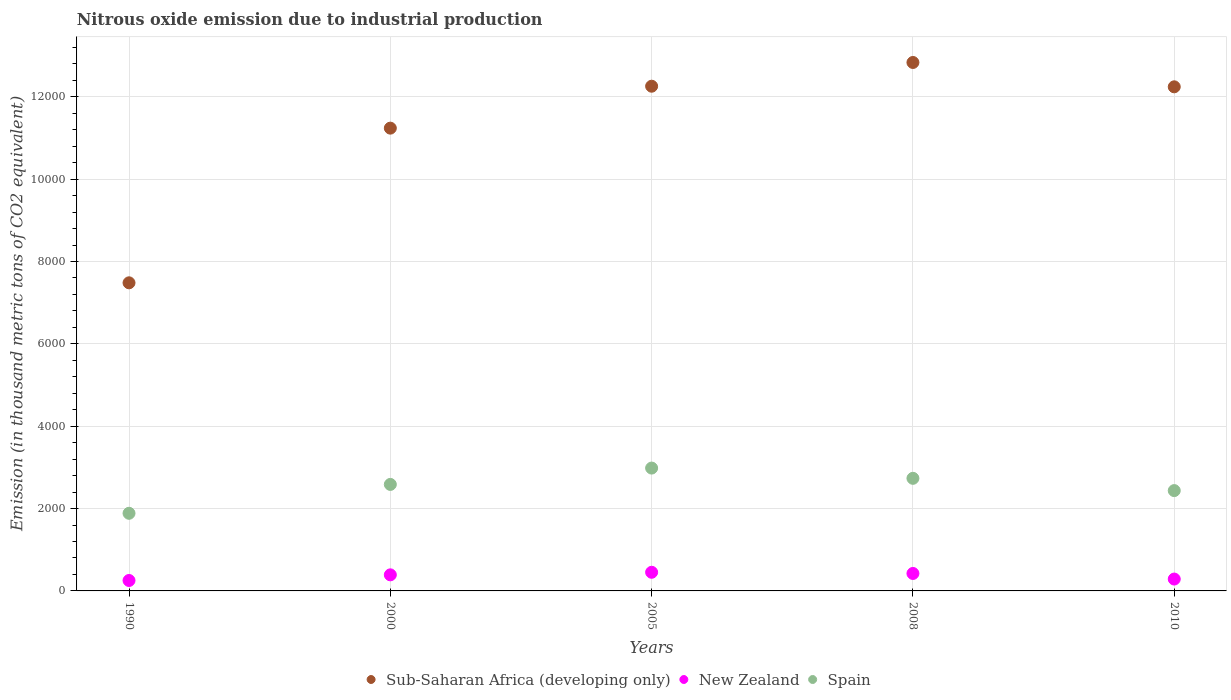Is the number of dotlines equal to the number of legend labels?
Provide a succinct answer. Yes. What is the amount of nitrous oxide emitted in New Zealand in 1990?
Offer a terse response. 253.4. Across all years, what is the maximum amount of nitrous oxide emitted in Spain?
Ensure brevity in your answer.  2983.4. Across all years, what is the minimum amount of nitrous oxide emitted in Sub-Saharan Africa (developing only)?
Make the answer very short. 7482.3. In which year was the amount of nitrous oxide emitted in New Zealand maximum?
Offer a terse response. 2005. What is the total amount of nitrous oxide emitted in New Zealand in the graph?
Offer a terse response. 1808.9. What is the difference between the amount of nitrous oxide emitted in Sub-Saharan Africa (developing only) in 1990 and that in 2010?
Keep it short and to the point. -4759.9. What is the difference between the amount of nitrous oxide emitted in Spain in 2010 and the amount of nitrous oxide emitted in New Zealand in 2008?
Offer a terse response. 2012.4. What is the average amount of nitrous oxide emitted in Sub-Saharan Africa (developing only) per year?
Provide a short and direct response. 1.12e+04. In the year 2000, what is the difference between the amount of nitrous oxide emitted in Spain and amount of nitrous oxide emitted in Sub-Saharan Africa (developing only)?
Your answer should be compact. -8652.2. What is the ratio of the amount of nitrous oxide emitted in Spain in 2008 to that in 2010?
Give a very brief answer. 1.12. What is the difference between the highest and the second highest amount of nitrous oxide emitted in Sub-Saharan Africa (developing only)?
Your answer should be very brief. 576.6. What is the difference between the highest and the lowest amount of nitrous oxide emitted in Spain?
Provide a succinct answer. 1098.1. Is the sum of the amount of nitrous oxide emitted in Sub-Saharan Africa (developing only) in 2008 and 2010 greater than the maximum amount of nitrous oxide emitted in New Zealand across all years?
Ensure brevity in your answer.  Yes. Does the amount of nitrous oxide emitted in Sub-Saharan Africa (developing only) monotonically increase over the years?
Your answer should be very brief. No. How many dotlines are there?
Your answer should be very brief. 3. How many years are there in the graph?
Offer a very short reply. 5. Are the values on the major ticks of Y-axis written in scientific E-notation?
Offer a very short reply. No. How are the legend labels stacked?
Give a very brief answer. Horizontal. What is the title of the graph?
Your answer should be compact. Nitrous oxide emission due to industrial production. What is the label or title of the Y-axis?
Provide a succinct answer. Emission (in thousand metric tons of CO2 equivalent). What is the Emission (in thousand metric tons of CO2 equivalent) of Sub-Saharan Africa (developing only) in 1990?
Provide a succinct answer. 7482.3. What is the Emission (in thousand metric tons of CO2 equivalent) in New Zealand in 1990?
Keep it short and to the point. 253.4. What is the Emission (in thousand metric tons of CO2 equivalent) of Spain in 1990?
Offer a very short reply. 1885.3. What is the Emission (in thousand metric tons of CO2 equivalent) in Sub-Saharan Africa (developing only) in 2000?
Your response must be concise. 1.12e+04. What is the Emission (in thousand metric tons of CO2 equivalent) in New Zealand in 2000?
Make the answer very short. 390.5. What is the Emission (in thousand metric tons of CO2 equivalent) of Spain in 2000?
Your response must be concise. 2586.5. What is the Emission (in thousand metric tons of CO2 equivalent) of Sub-Saharan Africa (developing only) in 2005?
Provide a succinct answer. 1.23e+04. What is the Emission (in thousand metric tons of CO2 equivalent) in New Zealand in 2005?
Your answer should be very brief. 452.7. What is the Emission (in thousand metric tons of CO2 equivalent) of Spain in 2005?
Your answer should be very brief. 2983.4. What is the Emission (in thousand metric tons of CO2 equivalent) in Sub-Saharan Africa (developing only) in 2008?
Ensure brevity in your answer.  1.28e+04. What is the Emission (in thousand metric tons of CO2 equivalent) in New Zealand in 2008?
Provide a short and direct response. 424. What is the Emission (in thousand metric tons of CO2 equivalent) of Spain in 2008?
Your answer should be compact. 2734.4. What is the Emission (in thousand metric tons of CO2 equivalent) of Sub-Saharan Africa (developing only) in 2010?
Offer a very short reply. 1.22e+04. What is the Emission (in thousand metric tons of CO2 equivalent) of New Zealand in 2010?
Offer a very short reply. 288.3. What is the Emission (in thousand metric tons of CO2 equivalent) in Spain in 2010?
Your response must be concise. 2436.4. Across all years, what is the maximum Emission (in thousand metric tons of CO2 equivalent) of Sub-Saharan Africa (developing only)?
Make the answer very short. 1.28e+04. Across all years, what is the maximum Emission (in thousand metric tons of CO2 equivalent) in New Zealand?
Provide a succinct answer. 452.7. Across all years, what is the maximum Emission (in thousand metric tons of CO2 equivalent) in Spain?
Provide a succinct answer. 2983.4. Across all years, what is the minimum Emission (in thousand metric tons of CO2 equivalent) of Sub-Saharan Africa (developing only)?
Provide a succinct answer. 7482.3. Across all years, what is the minimum Emission (in thousand metric tons of CO2 equivalent) of New Zealand?
Give a very brief answer. 253.4. Across all years, what is the minimum Emission (in thousand metric tons of CO2 equivalent) in Spain?
Keep it short and to the point. 1885.3. What is the total Emission (in thousand metric tons of CO2 equivalent) in Sub-Saharan Africa (developing only) in the graph?
Provide a succinct answer. 5.61e+04. What is the total Emission (in thousand metric tons of CO2 equivalent) in New Zealand in the graph?
Your answer should be very brief. 1808.9. What is the total Emission (in thousand metric tons of CO2 equivalent) of Spain in the graph?
Provide a short and direct response. 1.26e+04. What is the difference between the Emission (in thousand metric tons of CO2 equivalent) of Sub-Saharan Africa (developing only) in 1990 and that in 2000?
Your answer should be very brief. -3756.4. What is the difference between the Emission (in thousand metric tons of CO2 equivalent) in New Zealand in 1990 and that in 2000?
Offer a terse response. -137.1. What is the difference between the Emission (in thousand metric tons of CO2 equivalent) in Spain in 1990 and that in 2000?
Give a very brief answer. -701.2. What is the difference between the Emission (in thousand metric tons of CO2 equivalent) in Sub-Saharan Africa (developing only) in 1990 and that in 2005?
Your response must be concise. -4774.5. What is the difference between the Emission (in thousand metric tons of CO2 equivalent) in New Zealand in 1990 and that in 2005?
Your response must be concise. -199.3. What is the difference between the Emission (in thousand metric tons of CO2 equivalent) of Spain in 1990 and that in 2005?
Offer a very short reply. -1098.1. What is the difference between the Emission (in thousand metric tons of CO2 equivalent) in Sub-Saharan Africa (developing only) in 1990 and that in 2008?
Make the answer very short. -5351.1. What is the difference between the Emission (in thousand metric tons of CO2 equivalent) in New Zealand in 1990 and that in 2008?
Give a very brief answer. -170.6. What is the difference between the Emission (in thousand metric tons of CO2 equivalent) of Spain in 1990 and that in 2008?
Your answer should be very brief. -849.1. What is the difference between the Emission (in thousand metric tons of CO2 equivalent) of Sub-Saharan Africa (developing only) in 1990 and that in 2010?
Give a very brief answer. -4759.9. What is the difference between the Emission (in thousand metric tons of CO2 equivalent) of New Zealand in 1990 and that in 2010?
Your response must be concise. -34.9. What is the difference between the Emission (in thousand metric tons of CO2 equivalent) in Spain in 1990 and that in 2010?
Keep it short and to the point. -551.1. What is the difference between the Emission (in thousand metric tons of CO2 equivalent) of Sub-Saharan Africa (developing only) in 2000 and that in 2005?
Keep it short and to the point. -1018.1. What is the difference between the Emission (in thousand metric tons of CO2 equivalent) in New Zealand in 2000 and that in 2005?
Provide a short and direct response. -62.2. What is the difference between the Emission (in thousand metric tons of CO2 equivalent) in Spain in 2000 and that in 2005?
Ensure brevity in your answer.  -396.9. What is the difference between the Emission (in thousand metric tons of CO2 equivalent) of Sub-Saharan Africa (developing only) in 2000 and that in 2008?
Your answer should be very brief. -1594.7. What is the difference between the Emission (in thousand metric tons of CO2 equivalent) in New Zealand in 2000 and that in 2008?
Keep it short and to the point. -33.5. What is the difference between the Emission (in thousand metric tons of CO2 equivalent) in Spain in 2000 and that in 2008?
Your response must be concise. -147.9. What is the difference between the Emission (in thousand metric tons of CO2 equivalent) of Sub-Saharan Africa (developing only) in 2000 and that in 2010?
Ensure brevity in your answer.  -1003.5. What is the difference between the Emission (in thousand metric tons of CO2 equivalent) of New Zealand in 2000 and that in 2010?
Offer a terse response. 102.2. What is the difference between the Emission (in thousand metric tons of CO2 equivalent) of Spain in 2000 and that in 2010?
Your answer should be compact. 150.1. What is the difference between the Emission (in thousand metric tons of CO2 equivalent) of Sub-Saharan Africa (developing only) in 2005 and that in 2008?
Ensure brevity in your answer.  -576.6. What is the difference between the Emission (in thousand metric tons of CO2 equivalent) in New Zealand in 2005 and that in 2008?
Provide a succinct answer. 28.7. What is the difference between the Emission (in thousand metric tons of CO2 equivalent) in Spain in 2005 and that in 2008?
Keep it short and to the point. 249. What is the difference between the Emission (in thousand metric tons of CO2 equivalent) in New Zealand in 2005 and that in 2010?
Make the answer very short. 164.4. What is the difference between the Emission (in thousand metric tons of CO2 equivalent) in Spain in 2005 and that in 2010?
Give a very brief answer. 547. What is the difference between the Emission (in thousand metric tons of CO2 equivalent) of Sub-Saharan Africa (developing only) in 2008 and that in 2010?
Keep it short and to the point. 591.2. What is the difference between the Emission (in thousand metric tons of CO2 equivalent) in New Zealand in 2008 and that in 2010?
Your answer should be very brief. 135.7. What is the difference between the Emission (in thousand metric tons of CO2 equivalent) of Spain in 2008 and that in 2010?
Provide a succinct answer. 298. What is the difference between the Emission (in thousand metric tons of CO2 equivalent) in Sub-Saharan Africa (developing only) in 1990 and the Emission (in thousand metric tons of CO2 equivalent) in New Zealand in 2000?
Keep it short and to the point. 7091.8. What is the difference between the Emission (in thousand metric tons of CO2 equivalent) of Sub-Saharan Africa (developing only) in 1990 and the Emission (in thousand metric tons of CO2 equivalent) of Spain in 2000?
Your response must be concise. 4895.8. What is the difference between the Emission (in thousand metric tons of CO2 equivalent) of New Zealand in 1990 and the Emission (in thousand metric tons of CO2 equivalent) of Spain in 2000?
Keep it short and to the point. -2333.1. What is the difference between the Emission (in thousand metric tons of CO2 equivalent) in Sub-Saharan Africa (developing only) in 1990 and the Emission (in thousand metric tons of CO2 equivalent) in New Zealand in 2005?
Offer a terse response. 7029.6. What is the difference between the Emission (in thousand metric tons of CO2 equivalent) in Sub-Saharan Africa (developing only) in 1990 and the Emission (in thousand metric tons of CO2 equivalent) in Spain in 2005?
Make the answer very short. 4498.9. What is the difference between the Emission (in thousand metric tons of CO2 equivalent) in New Zealand in 1990 and the Emission (in thousand metric tons of CO2 equivalent) in Spain in 2005?
Your answer should be compact. -2730. What is the difference between the Emission (in thousand metric tons of CO2 equivalent) in Sub-Saharan Africa (developing only) in 1990 and the Emission (in thousand metric tons of CO2 equivalent) in New Zealand in 2008?
Your answer should be compact. 7058.3. What is the difference between the Emission (in thousand metric tons of CO2 equivalent) in Sub-Saharan Africa (developing only) in 1990 and the Emission (in thousand metric tons of CO2 equivalent) in Spain in 2008?
Make the answer very short. 4747.9. What is the difference between the Emission (in thousand metric tons of CO2 equivalent) of New Zealand in 1990 and the Emission (in thousand metric tons of CO2 equivalent) of Spain in 2008?
Your response must be concise. -2481. What is the difference between the Emission (in thousand metric tons of CO2 equivalent) in Sub-Saharan Africa (developing only) in 1990 and the Emission (in thousand metric tons of CO2 equivalent) in New Zealand in 2010?
Your answer should be very brief. 7194. What is the difference between the Emission (in thousand metric tons of CO2 equivalent) in Sub-Saharan Africa (developing only) in 1990 and the Emission (in thousand metric tons of CO2 equivalent) in Spain in 2010?
Ensure brevity in your answer.  5045.9. What is the difference between the Emission (in thousand metric tons of CO2 equivalent) in New Zealand in 1990 and the Emission (in thousand metric tons of CO2 equivalent) in Spain in 2010?
Your answer should be very brief. -2183. What is the difference between the Emission (in thousand metric tons of CO2 equivalent) in Sub-Saharan Africa (developing only) in 2000 and the Emission (in thousand metric tons of CO2 equivalent) in New Zealand in 2005?
Offer a very short reply. 1.08e+04. What is the difference between the Emission (in thousand metric tons of CO2 equivalent) of Sub-Saharan Africa (developing only) in 2000 and the Emission (in thousand metric tons of CO2 equivalent) of Spain in 2005?
Ensure brevity in your answer.  8255.3. What is the difference between the Emission (in thousand metric tons of CO2 equivalent) of New Zealand in 2000 and the Emission (in thousand metric tons of CO2 equivalent) of Spain in 2005?
Keep it short and to the point. -2592.9. What is the difference between the Emission (in thousand metric tons of CO2 equivalent) in Sub-Saharan Africa (developing only) in 2000 and the Emission (in thousand metric tons of CO2 equivalent) in New Zealand in 2008?
Offer a terse response. 1.08e+04. What is the difference between the Emission (in thousand metric tons of CO2 equivalent) in Sub-Saharan Africa (developing only) in 2000 and the Emission (in thousand metric tons of CO2 equivalent) in Spain in 2008?
Make the answer very short. 8504.3. What is the difference between the Emission (in thousand metric tons of CO2 equivalent) of New Zealand in 2000 and the Emission (in thousand metric tons of CO2 equivalent) of Spain in 2008?
Offer a terse response. -2343.9. What is the difference between the Emission (in thousand metric tons of CO2 equivalent) of Sub-Saharan Africa (developing only) in 2000 and the Emission (in thousand metric tons of CO2 equivalent) of New Zealand in 2010?
Provide a succinct answer. 1.10e+04. What is the difference between the Emission (in thousand metric tons of CO2 equivalent) of Sub-Saharan Africa (developing only) in 2000 and the Emission (in thousand metric tons of CO2 equivalent) of Spain in 2010?
Your answer should be compact. 8802.3. What is the difference between the Emission (in thousand metric tons of CO2 equivalent) of New Zealand in 2000 and the Emission (in thousand metric tons of CO2 equivalent) of Spain in 2010?
Your response must be concise. -2045.9. What is the difference between the Emission (in thousand metric tons of CO2 equivalent) in Sub-Saharan Africa (developing only) in 2005 and the Emission (in thousand metric tons of CO2 equivalent) in New Zealand in 2008?
Offer a terse response. 1.18e+04. What is the difference between the Emission (in thousand metric tons of CO2 equivalent) in Sub-Saharan Africa (developing only) in 2005 and the Emission (in thousand metric tons of CO2 equivalent) in Spain in 2008?
Your response must be concise. 9522.4. What is the difference between the Emission (in thousand metric tons of CO2 equivalent) of New Zealand in 2005 and the Emission (in thousand metric tons of CO2 equivalent) of Spain in 2008?
Provide a succinct answer. -2281.7. What is the difference between the Emission (in thousand metric tons of CO2 equivalent) in Sub-Saharan Africa (developing only) in 2005 and the Emission (in thousand metric tons of CO2 equivalent) in New Zealand in 2010?
Your response must be concise. 1.20e+04. What is the difference between the Emission (in thousand metric tons of CO2 equivalent) in Sub-Saharan Africa (developing only) in 2005 and the Emission (in thousand metric tons of CO2 equivalent) in Spain in 2010?
Keep it short and to the point. 9820.4. What is the difference between the Emission (in thousand metric tons of CO2 equivalent) of New Zealand in 2005 and the Emission (in thousand metric tons of CO2 equivalent) of Spain in 2010?
Make the answer very short. -1983.7. What is the difference between the Emission (in thousand metric tons of CO2 equivalent) in Sub-Saharan Africa (developing only) in 2008 and the Emission (in thousand metric tons of CO2 equivalent) in New Zealand in 2010?
Give a very brief answer. 1.25e+04. What is the difference between the Emission (in thousand metric tons of CO2 equivalent) in Sub-Saharan Africa (developing only) in 2008 and the Emission (in thousand metric tons of CO2 equivalent) in Spain in 2010?
Make the answer very short. 1.04e+04. What is the difference between the Emission (in thousand metric tons of CO2 equivalent) of New Zealand in 2008 and the Emission (in thousand metric tons of CO2 equivalent) of Spain in 2010?
Offer a terse response. -2012.4. What is the average Emission (in thousand metric tons of CO2 equivalent) in Sub-Saharan Africa (developing only) per year?
Your response must be concise. 1.12e+04. What is the average Emission (in thousand metric tons of CO2 equivalent) in New Zealand per year?
Provide a short and direct response. 361.78. What is the average Emission (in thousand metric tons of CO2 equivalent) of Spain per year?
Make the answer very short. 2525.2. In the year 1990, what is the difference between the Emission (in thousand metric tons of CO2 equivalent) of Sub-Saharan Africa (developing only) and Emission (in thousand metric tons of CO2 equivalent) of New Zealand?
Your answer should be compact. 7228.9. In the year 1990, what is the difference between the Emission (in thousand metric tons of CO2 equivalent) of Sub-Saharan Africa (developing only) and Emission (in thousand metric tons of CO2 equivalent) of Spain?
Give a very brief answer. 5597. In the year 1990, what is the difference between the Emission (in thousand metric tons of CO2 equivalent) of New Zealand and Emission (in thousand metric tons of CO2 equivalent) of Spain?
Your answer should be compact. -1631.9. In the year 2000, what is the difference between the Emission (in thousand metric tons of CO2 equivalent) in Sub-Saharan Africa (developing only) and Emission (in thousand metric tons of CO2 equivalent) in New Zealand?
Offer a terse response. 1.08e+04. In the year 2000, what is the difference between the Emission (in thousand metric tons of CO2 equivalent) in Sub-Saharan Africa (developing only) and Emission (in thousand metric tons of CO2 equivalent) in Spain?
Make the answer very short. 8652.2. In the year 2000, what is the difference between the Emission (in thousand metric tons of CO2 equivalent) of New Zealand and Emission (in thousand metric tons of CO2 equivalent) of Spain?
Your response must be concise. -2196. In the year 2005, what is the difference between the Emission (in thousand metric tons of CO2 equivalent) in Sub-Saharan Africa (developing only) and Emission (in thousand metric tons of CO2 equivalent) in New Zealand?
Offer a very short reply. 1.18e+04. In the year 2005, what is the difference between the Emission (in thousand metric tons of CO2 equivalent) in Sub-Saharan Africa (developing only) and Emission (in thousand metric tons of CO2 equivalent) in Spain?
Give a very brief answer. 9273.4. In the year 2005, what is the difference between the Emission (in thousand metric tons of CO2 equivalent) of New Zealand and Emission (in thousand metric tons of CO2 equivalent) of Spain?
Make the answer very short. -2530.7. In the year 2008, what is the difference between the Emission (in thousand metric tons of CO2 equivalent) of Sub-Saharan Africa (developing only) and Emission (in thousand metric tons of CO2 equivalent) of New Zealand?
Offer a terse response. 1.24e+04. In the year 2008, what is the difference between the Emission (in thousand metric tons of CO2 equivalent) in Sub-Saharan Africa (developing only) and Emission (in thousand metric tons of CO2 equivalent) in Spain?
Keep it short and to the point. 1.01e+04. In the year 2008, what is the difference between the Emission (in thousand metric tons of CO2 equivalent) of New Zealand and Emission (in thousand metric tons of CO2 equivalent) of Spain?
Provide a succinct answer. -2310.4. In the year 2010, what is the difference between the Emission (in thousand metric tons of CO2 equivalent) in Sub-Saharan Africa (developing only) and Emission (in thousand metric tons of CO2 equivalent) in New Zealand?
Your answer should be compact. 1.20e+04. In the year 2010, what is the difference between the Emission (in thousand metric tons of CO2 equivalent) of Sub-Saharan Africa (developing only) and Emission (in thousand metric tons of CO2 equivalent) of Spain?
Offer a terse response. 9805.8. In the year 2010, what is the difference between the Emission (in thousand metric tons of CO2 equivalent) in New Zealand and Emission (in thousand metric tons of CO2 equivalent) in Spain?
Ensure brevity in your answer.  -2148.1. What is the ratio of the Emission (in thousand metric tons of CO2 equivalent) of Sub-Saharan Africa (developing only) in 1990 to that in 2000?
Your answer should be compact. 0.67. What is the ratio of the Emission (in thousand metric tons of CO2 equivalent) of New Zealand in 1990 to that in 2000?
Provide a short and direct response. 0.65. What is the ratio of the Emission (in thousand metric tons of CO2 equivalent) in Spain in 1990 to that in 2000?
Give a very brief answer. 0.73. What is the ratio of the Emission (in thousand metric tons of CO2 equivalent) in Sub-Saharan Africa (developing only) in 1990 to that in 2005?
Offer a very short reply. 0.61. What is the ratio of the Emission (in thousand metric tons of CO2 equivalent) in New Zealand in 1990 to that in 2005?
Provide a short and direct response. 0.56. What is the ratio of the Emission (in thousand metric tons of CO2 equivalent) in Spain in 1990 to that in 2005?
Your answer should be very brief. 0.63. What is the ratio of the Emission (in thousand metric tons of CO2 equivalent) of Sub-Saharan Africa (developing only) in 1990 to that in 2008?
Provide a succinct answer. 0.58. What is the ratio of the Emission (in thousand metric tons of CO2 equivalent) in New Zealand in 1990 to that in 2008?
Provide a succinct answer. 0.6. What is the ratio of the Emission (in thousand metric tons of CO2 equivalent) of Spain in 1990 to that in 2008?
Provide a succinct answer. 0.69. What is the ratio of the Emission (in thousand metric tons of CO2 equivalent) of Sub-Saharan Africa (developing only) in 1990 to that in 2010?
Give a very brief answer. 0.61. What is the ratio of the Emission (in thousand metric tons of CO2 equivalent) in New Zealand in 1990 to that in 2010?
Offer a terse response. 0.88. What is the ratio of the Emission (in thousand metric tons of CO2 equivalent) of Spain in 1990 to that in 2010?
Your answer should be very brief. 0.77. What is the ratio of the Emission (in thousand metric tons of CO2 equivalent) in Sub-Saharan Africa (developing only) in 2000 to that in 2005?
Offer a terse response. 0.92. What is the ratio of the Emission (in thousand metric tons of CO2 equivalent) of New Zealand in 2000 to that in 2005?
Provide a short and direct response. 0.86. What is the ratio of the Emission (in thousand metric tons of CO2 equivalent) in Spain in 2000 to that in 2005?
Give a very brief answer. 0.87. What is the ratio of the Emission (in thousand metric tons of CO2 equivalent) of Sub-Saharan Africa (developing only) in 2000 to that in 2008?
Your response must be concise. 0.88. What is the ratio of the Emission (in thousand metric tons of CO2 equivalent) of New Zealand in 2000 to that in 2008?
Provide a short and direct response. 0.92. What is the ratio of the Emission (in thousand metric tons of CO2 equivalent) in Spain in 2000 to that in 2008?
Keep it short and to the point. 0.95. What is the ratio of the Emission (in thousand metric tons of CO2 equivalent) of Sub-Saharan Africa (developing only) in 2000 to that in 2010?
Provide a short and direct response. 0.92. What is the ratio of the Emission (in thousand metric tons of CO2 equivalent) of New Zealand in 2000 to that in 2010?
Give a very brief answer. 1.35. What is the ratio of the Emission (in thousand metric tons of CO2 equivalent) in Spain in 2000 to that in 2010?
Your response must be concise. 1.06. What is the ratio of the Emission (in thousand metric tons of CO2 equivalent) in Sub-Saharan Africa (developing only) in 2005 to that in 2008?
Your response must be concise. 0.96. What is the ratio of the Emission (in thousand metric tons of CO2 equivalent) in New Zealand in 2005 to that in 2008?
Offer a terse response. 1.07. What is the ratio of the Emission (in thousand metric tons of CO2 equivalent) in Spain in 2005 to that in 2008?
Your response must be concise. 1.09. What is the ratio of the Emission (in thousand metric tons of CO2 equivalent) in Sub-Saharan Africa (developing only) in 2005 to that in 2010?
Ensure brevity in your answer.  1. What is the ratio of the Emission (in thousand metric tons of CO2 equivalent) of New Zealand in 2005 to that in 2010?
Ensure brevity in your answer.  1.57. What is the ratio of the Emission (in thousand metric tons of CO2 equivalent) of Spain in 2005 to that in 2010?
Keep it short and to the point. 1.22. What is the ratio of the Emission (in thousand metric tons of CO2 equivalent) in Sub-Saharan Africa (developing only) in 2008 to that in 2010?
Provide a succinct answer. 1.05. What is the ratio of the Emission (in thousand metric tons of CO2 equivalent) in New Zealand in 2008 to that in 2010?
Your answer should be very brief. 1.47. What is the ratio of the Emission (in thousand metric tons of CO2 equivalent) in Spain in 2008 to that in 2010?
Make the answer very short. 1.12. What is the difference between the highest and the second highest Emission (in thousand metric tons of CO2 equivalent) in Sub-Saharan Africa (developing only)?
Make the answer very short. 576.6. What is the difference between the highest and the second highest Emission (in thousand metric tons of CO2 equivalent) of New Zealand?
Your response must be concise. 28.7. What is the difference between the highest and the second highest Emission (in thousand metric tons of CO2 equivalent) in Spain?
Offer a terse response. 249. What is the difference between the highest and the lowest Emission (in thousand metric tons of CO2 equivalent) in Sub-Saharan Africa (developing only)?
Your answer should be compact. 5351.1. What is the difference between the highest and the lowest Emission (in thousand metric tons of CO2 equivalent) of New Zealand?
Give a very brief answer. 199.3. What is the difference between the highest and the lowest Emission (in thousand metric tons of CO2 equivalent) in Spain?
Give a very brief answer. 1098.1. 